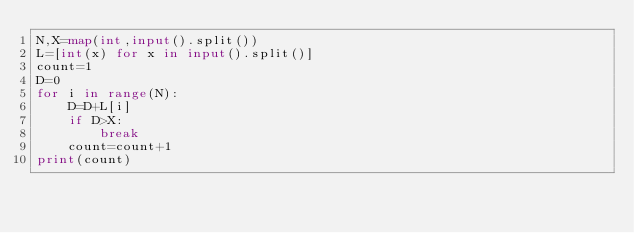Convert code to text. <code><loc_0><loc_0><loc_500><loc_500><_Python_>N,X=map(int,input().split())
L=[int(x) for x in input().split()]
count=1
D=0
for i in range(N):
    D=D+L[i]
    if D>X:
        break
    count=count+1
print(count)
</code> 